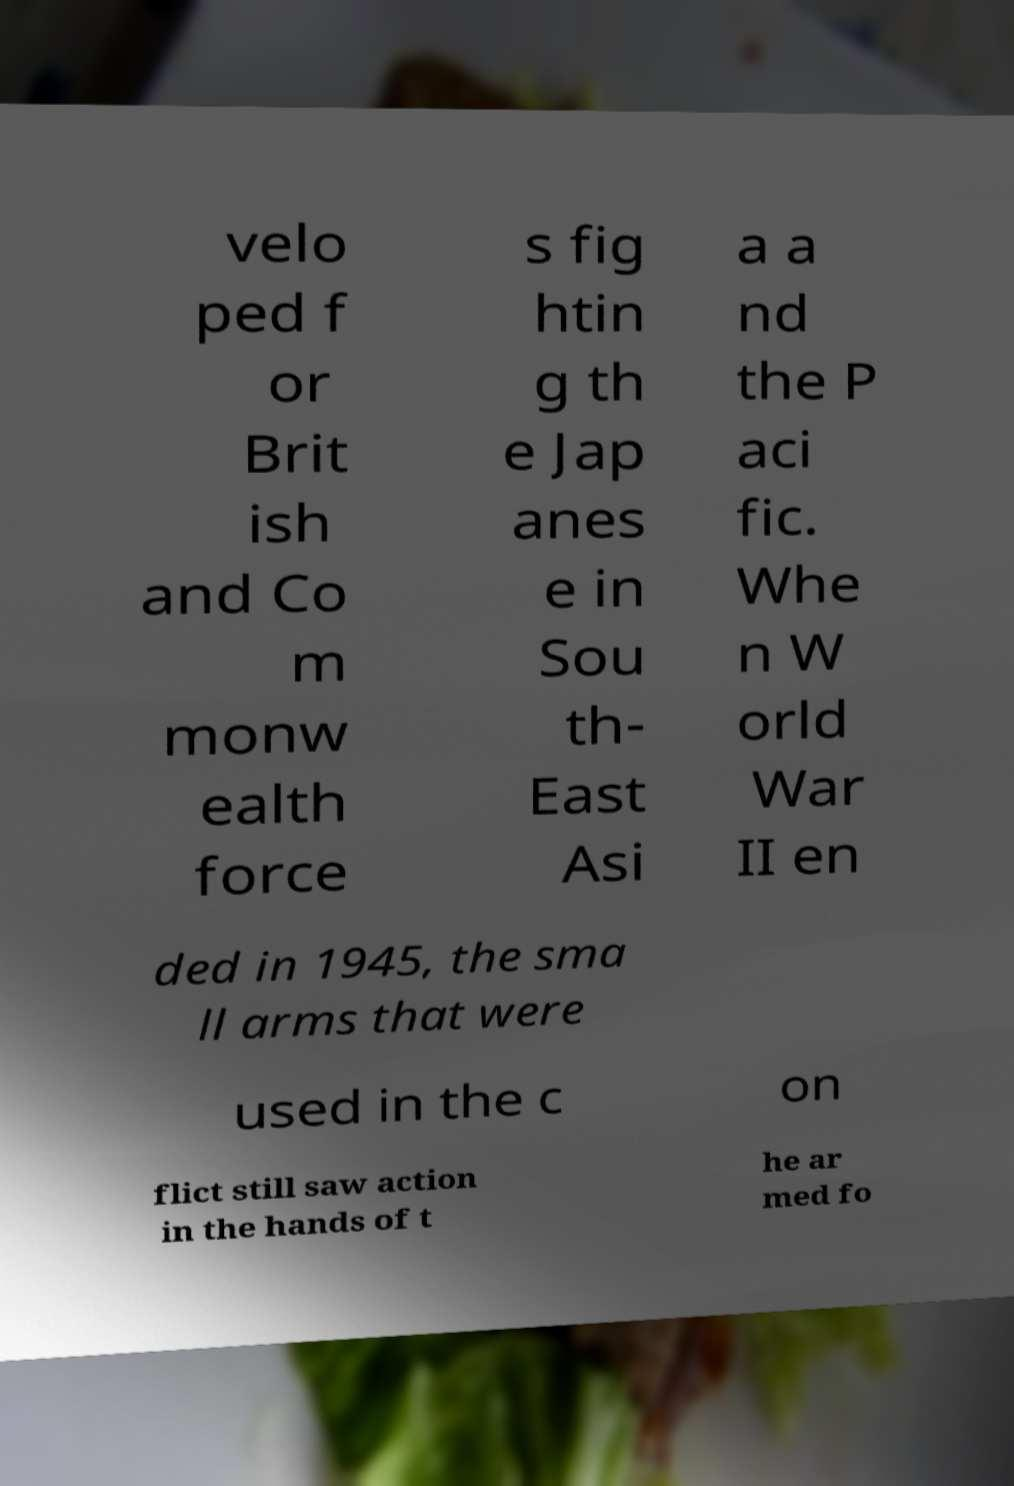Please identify and transcribe the text found in this image. velo ped f or Brit ish and Co m monw ealth force s fig htin g th e Jap anes e in Sou th- East Asi a a nd the P aci fic. Whe n W orld War II en ded in 1945, the sma ll arms that were used in the c on flict still saw action in the hands of t he ar med fo 